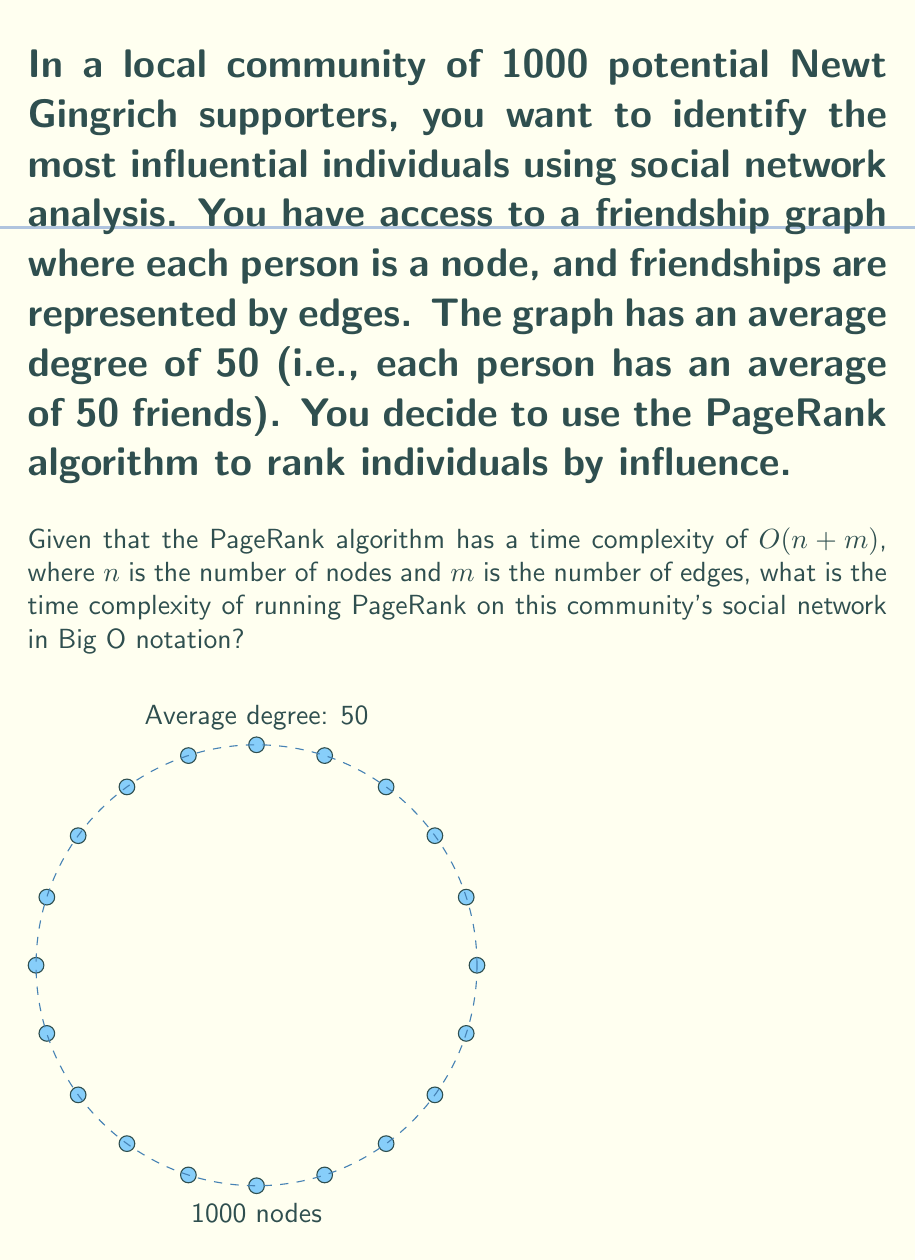Can you answer this question? Let's approach this step-by-step:

1) First, we need to understand the given information:
   - Number of nodes (people) $n = 1000$
   - Average degree (friends per person) = 50

2) In a graph, each edge connects two nodes. However, in the context of friendships, each connection is counted twice (A is friends with B, and B is friends with A). So, to get the number of edges, we need to:
   - Multiply the number of nodes by the average degree
   - Divide by 2 to avoid double-counting

3) Let's calculate the number of edges $m$:
   $$m = \frac{n \times \text{average degree}}{2} = \frac{1000 \times 50}{2} = 25000$$

4) Now, we have:
   - $n = 1000$
   - $m = 25000$

5) The time complexity of PageRank is $O(n + m)$. Let's substitute our values:
   $$O(n + m) = O(1000 + 25000) = O(26000)$$

6) In Big O notation, we drop constants and consider only the highest order term. 26000 is a constant, so we can simplify this to:
   $$O(26000) = O(1)$$

However, this simplification to $O(1)$ would be misleading as it suggests the algorithm runs in constant time regardless of input size, which is not true for PageRank.

7) Instead, we should express the complexity in terms of $n$. We know that $m = 25n$ in this case, so:
   $$O(n + m) = O(n + 25n) = O(26n) = O(n)$$

This accurately reflects that the time complexity grows linearly with the number of nodes.
Answer: $O(n)$ 